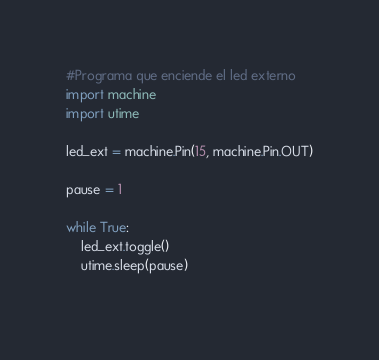Convert code to text. <code><loc_0><loc_0><loc_500><loc_500><_Python_>#Programa que enciende el led externo
import machine
import utime

led_ext = machine.Pin(15, machine.Pin.OUT)

pause = 1

while True:
    led_ext.toggle()
    utime.sleep(pause)
    
</code> 